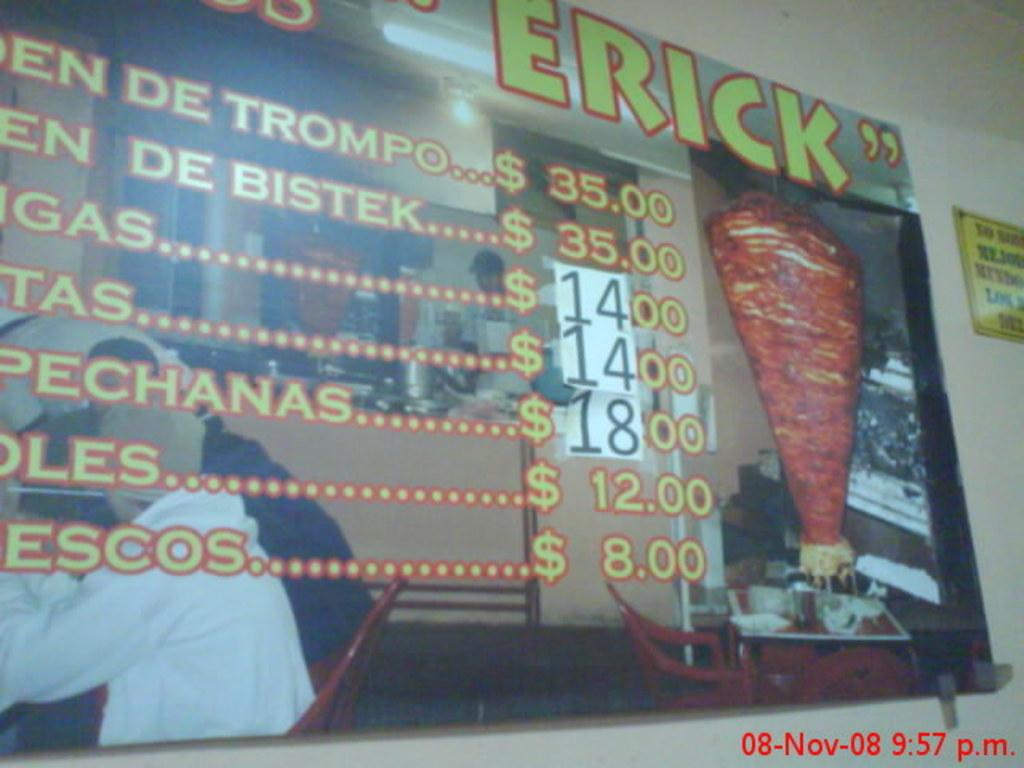<image>
Create a compact narrative representing the image presented. A food menu on which the least expensive item is $8.00. 